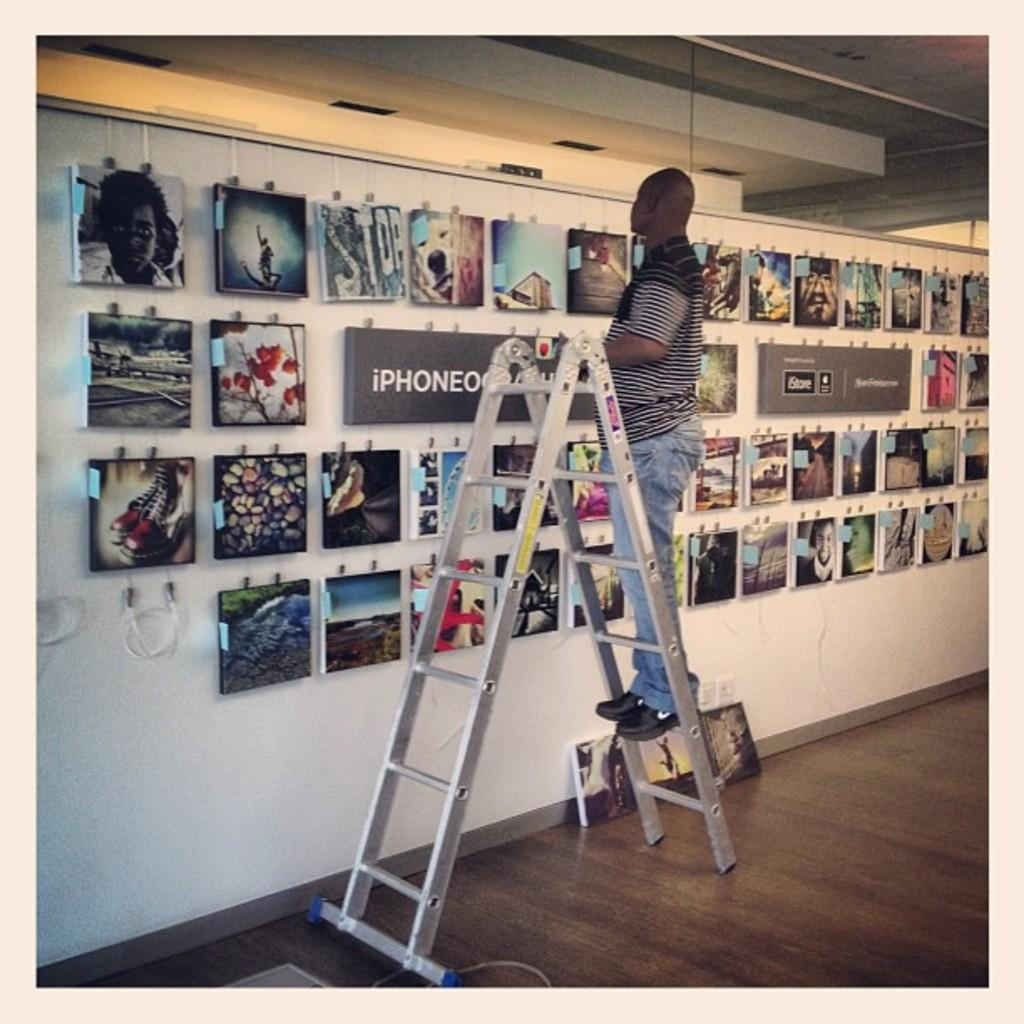<image>
Give a short and clear explanation of the subsequent image. a person on a ladder with the word iPhone in front of them 